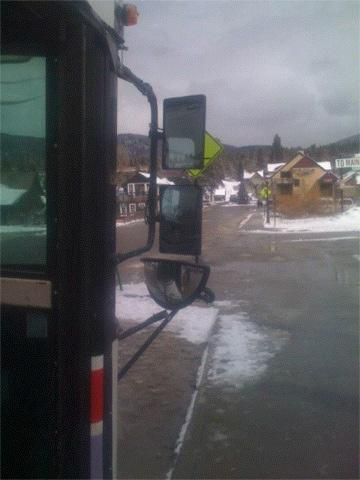What is the main vehicle shown in the image? A bus driving through the neighborhood. Explain the condition of the road in the image. The road is wet, with melting snow, patches of snow and ice, and water on the street. Count the number of side mirrors on the bus and describe their color. There are three side mirrors on the bus, and they are gray. Mention any additional road elements or objects seen around the bus or the road. There is an open bus door, a streetlamp on the side of the road, a directional sign on a roadway, and yellow caution signs on the street. Describe the nature elements present in the image. Large trees grow on the hills, mountains are in the distance, and there are white clouds in the blue sky. Provide a description of the weather and sky conditions. The sky is gray and cloudy with white clouds in the blue sky. What is the color and type of the featured house in the image? The featured house is a brown two-story house. Describe the scene depicted on the street in the image. A bus is driving through the neighborhood, with melting snow on the street, houses with snow on their roofs, and hills in the background. Mention any signage present in the image and their attributes. There is a four-sided yellow traffic signal, a white and black street sign, a yellow warning sign on the street, and a red and purple stripe beside a bus door. In terms of people, who can be seen in the image, and what activity are they engaged in? A couple is walking on the sidewalk. 